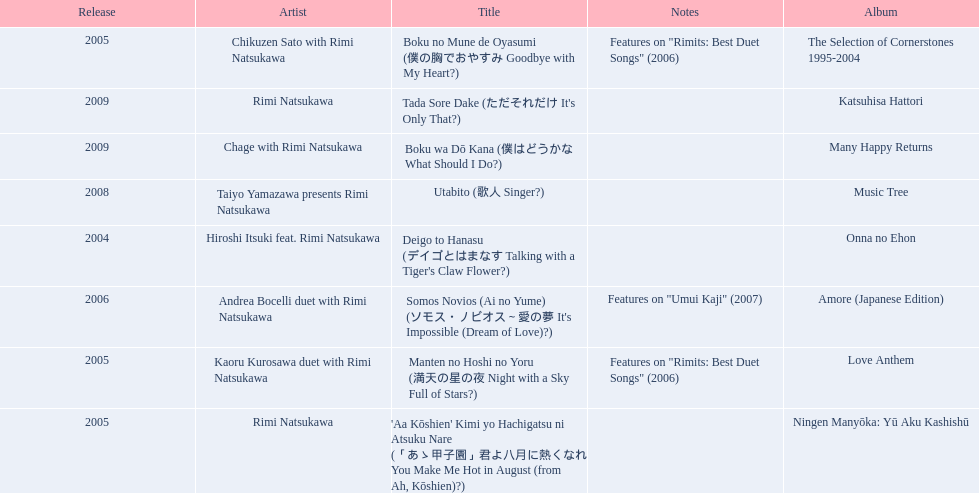Which title of the rimi natsukawa discography was released in the 2004? Deigo to Hanasu (デイゴとはまなす Talking with a Tiger's Claw Flower?). Which title has notes that features on/rimits. best duet songs\2006 Manten no Hoshi no Yoru (満天の星の夜 Night with a Sky Full of Stars?). Which title share the same notes as night with a sky full of stars? Boku no Mune de Oyasumi (僕の胸でおやすみ Goodbye with My Heart?). 